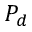Convert formula to latex. <formula><loc_0><loc_0><loc_500><loc_500>P _ { d }</formula> 